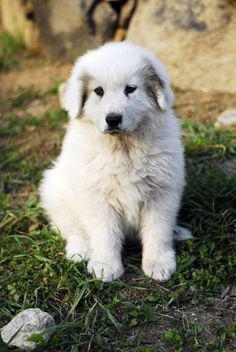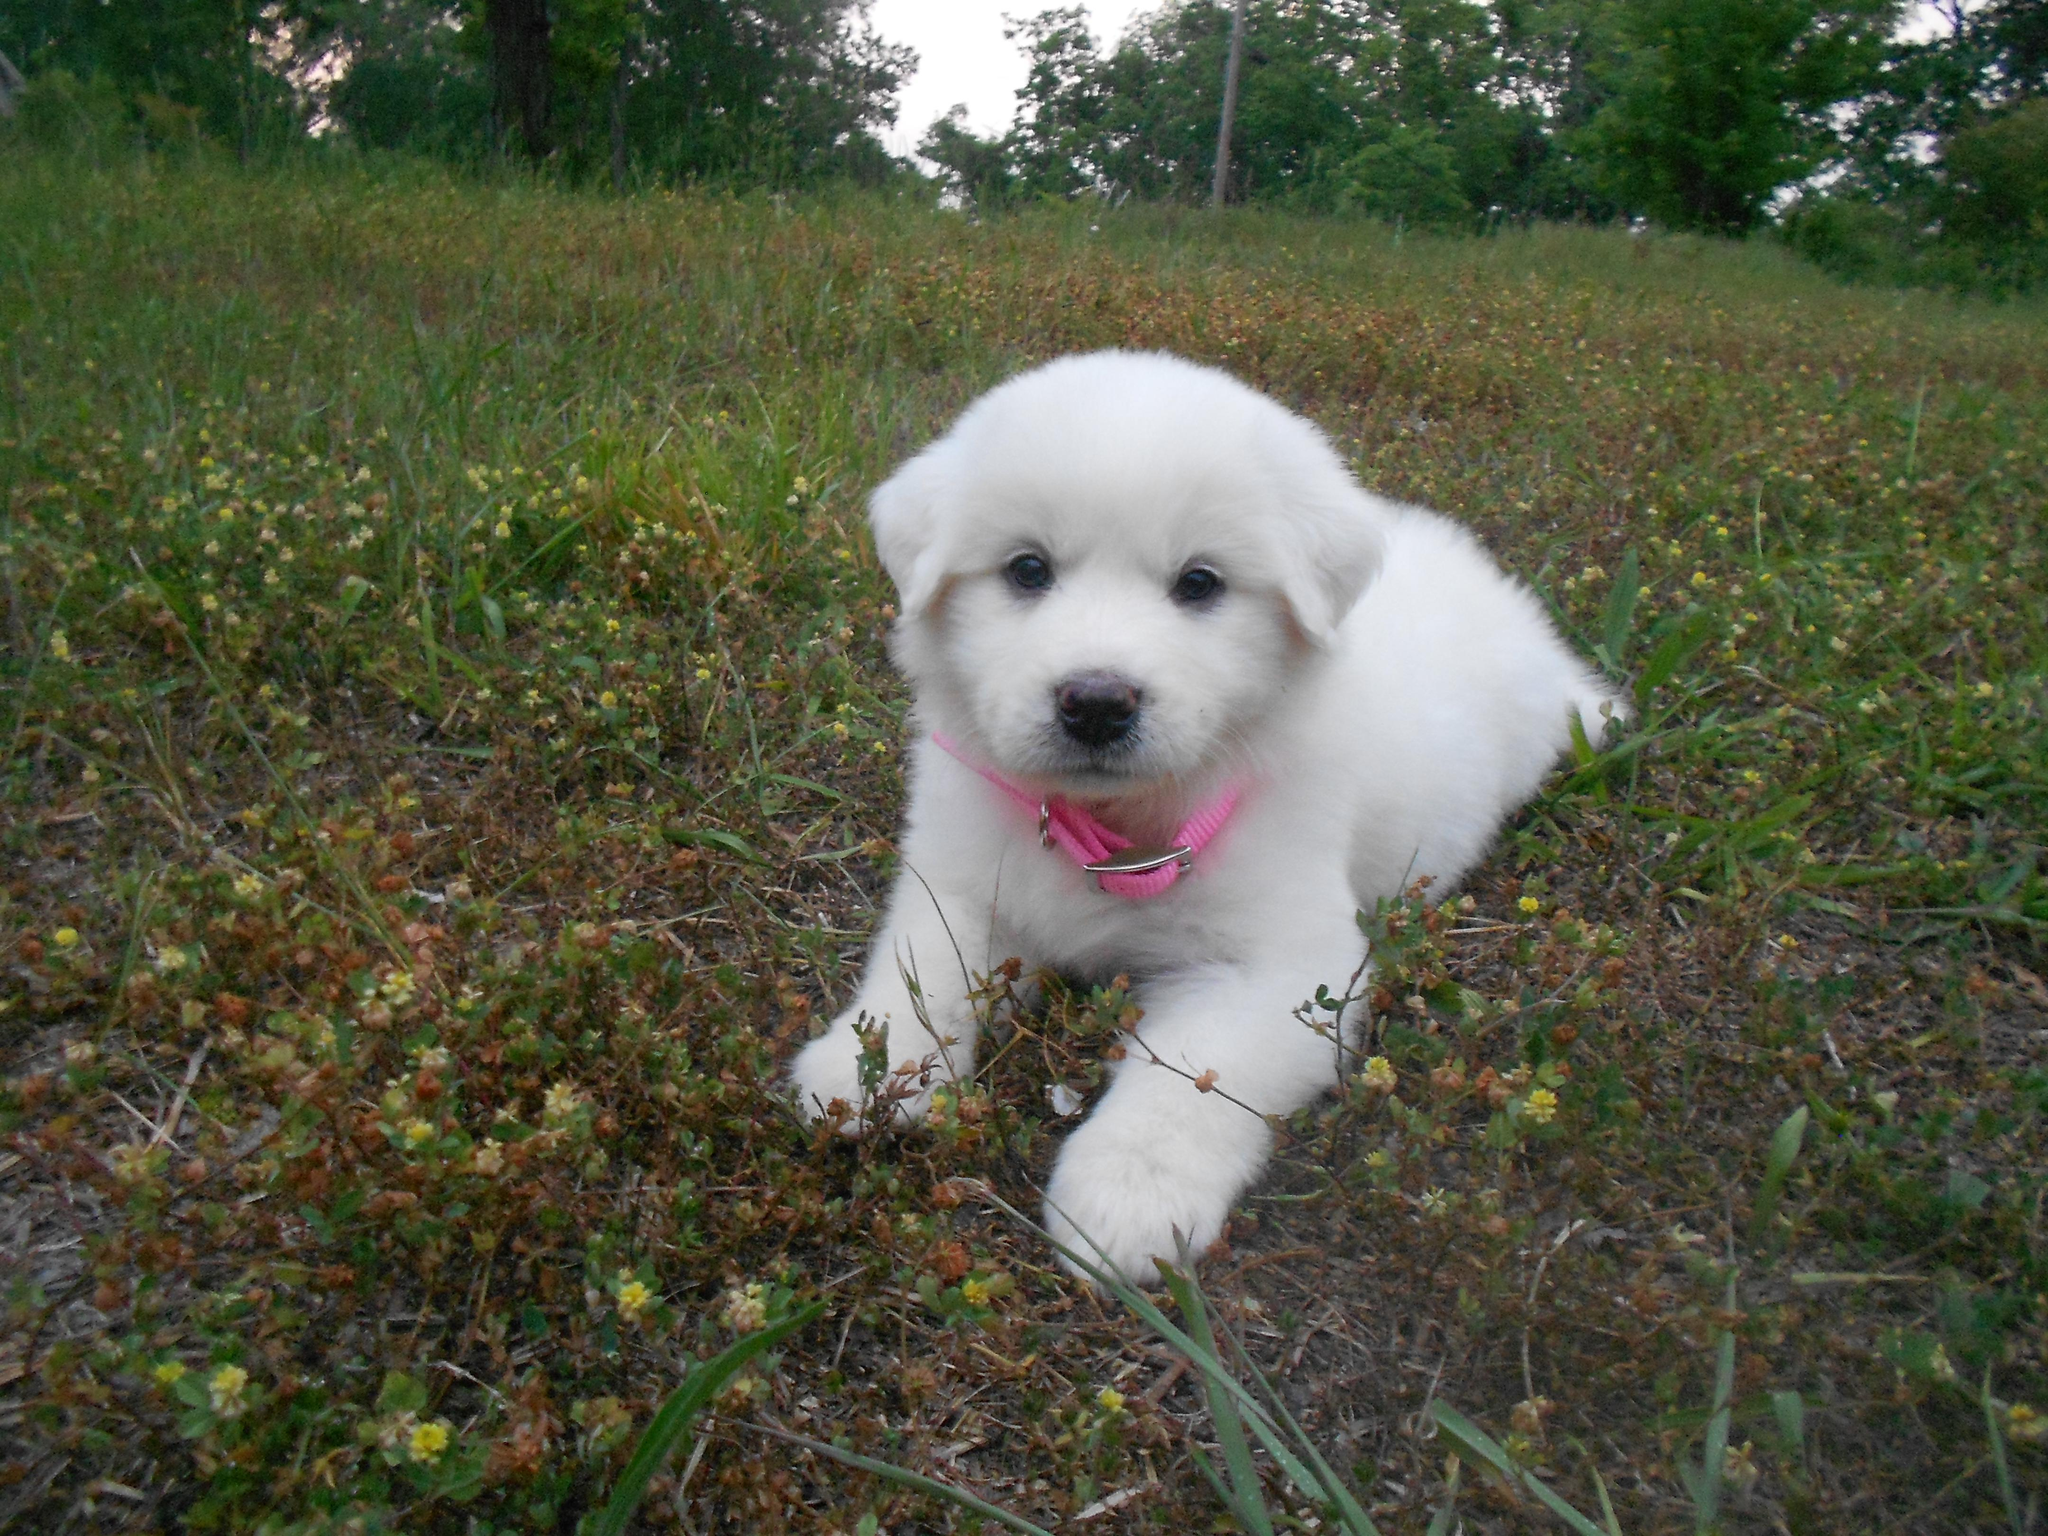The first image is the image on the left, the second image is the image on the right. Examine the images to the left and right. Is the description "One image shows an adult white dog standing on all fours in a grassy area." accurate? Answer yes or no. No. The first image is the image on the left, the second image is the image on the right. Given the left and right images, does the statement "A single white dog is laying on the grass in the image on the right." hold true? Answer yes or no. Yes. 